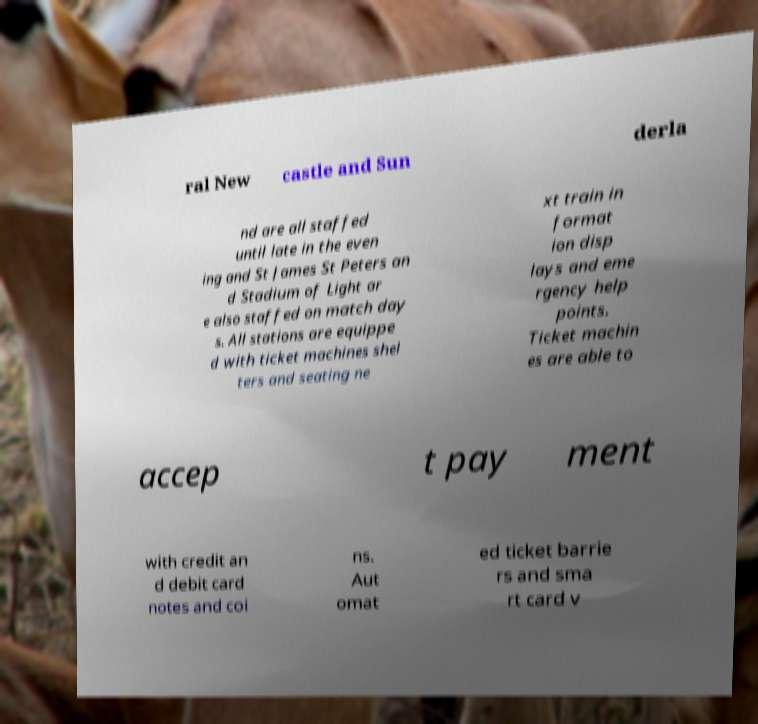What messages or text are displayed in this image? I need them in a readable, typed format. ral New castle and Sun derla nd are all staffed until late in the even ing and St James St Peters an d Stadium of Light ar e also staffed on match day s. All stations are equippe d with ticket machines shel ters and seating ne xt train in format ion disp lays and eme rgency help points. Ticket machin es are able to accep t pay ment with credit an d debit card notes and coi ns. Aut omat ed ticket barrie rs and sma rt card v 